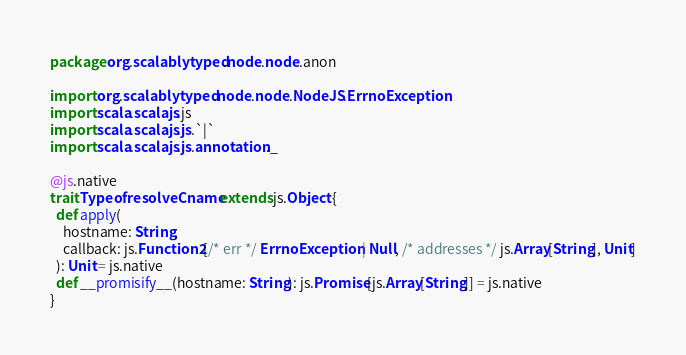<code> <loc_0><loc_0><loc_500><loc_500><_Scala_>package org.scalablytyped.node.node.anon

import org.scalablytyped.node.node.NodeJS.ErrnoException
import scala.scalajs.js
import scala.scalajs.js.`|`
import scala.scalajs.js.annotation._

@js.native
trait TypeofresolveCname extends js.Object {
  def apply(
    hostname: String,
    callback: js.Function2[/* err */ ErrnoException | Null, /* addresses */ js.Array[String], Unit]
  ): Unit = js.native
  def __promisify__(hostname: String): js.Promise[js.Array[String]] = js.native
}

</code> 